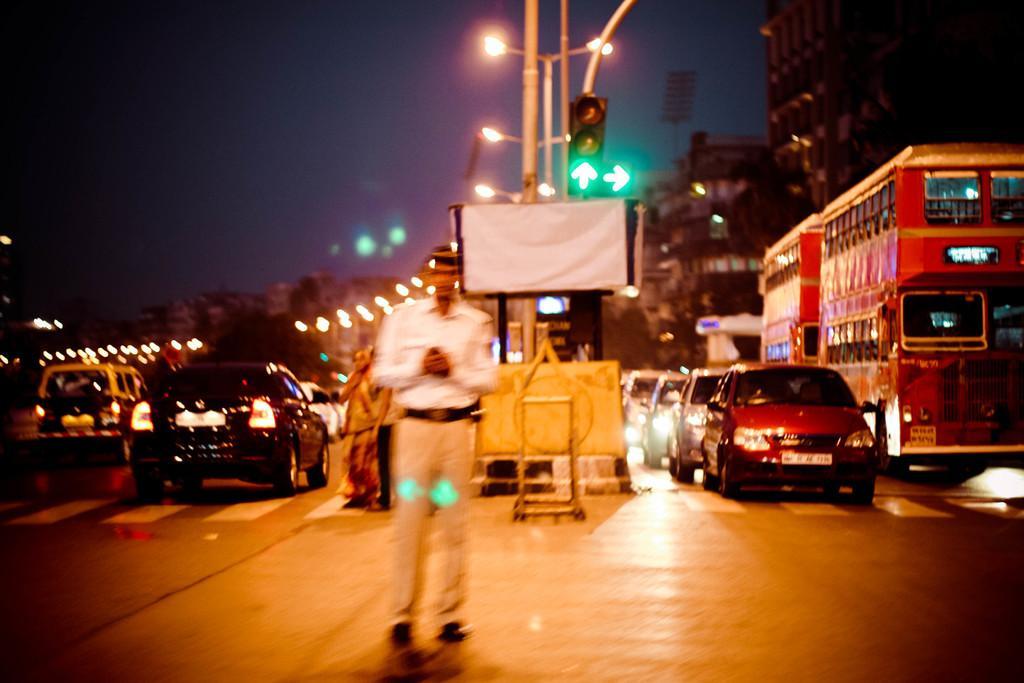How would you summarize this image in a sentence or two? At the bottom of this image, there is a person in a uniform, standing on a road. On the left side, there are vehicles and persons on the road. On the right side, there are vehicles on the road and there are lights attached to the poles. In the background, there are buildings and there is sky. 